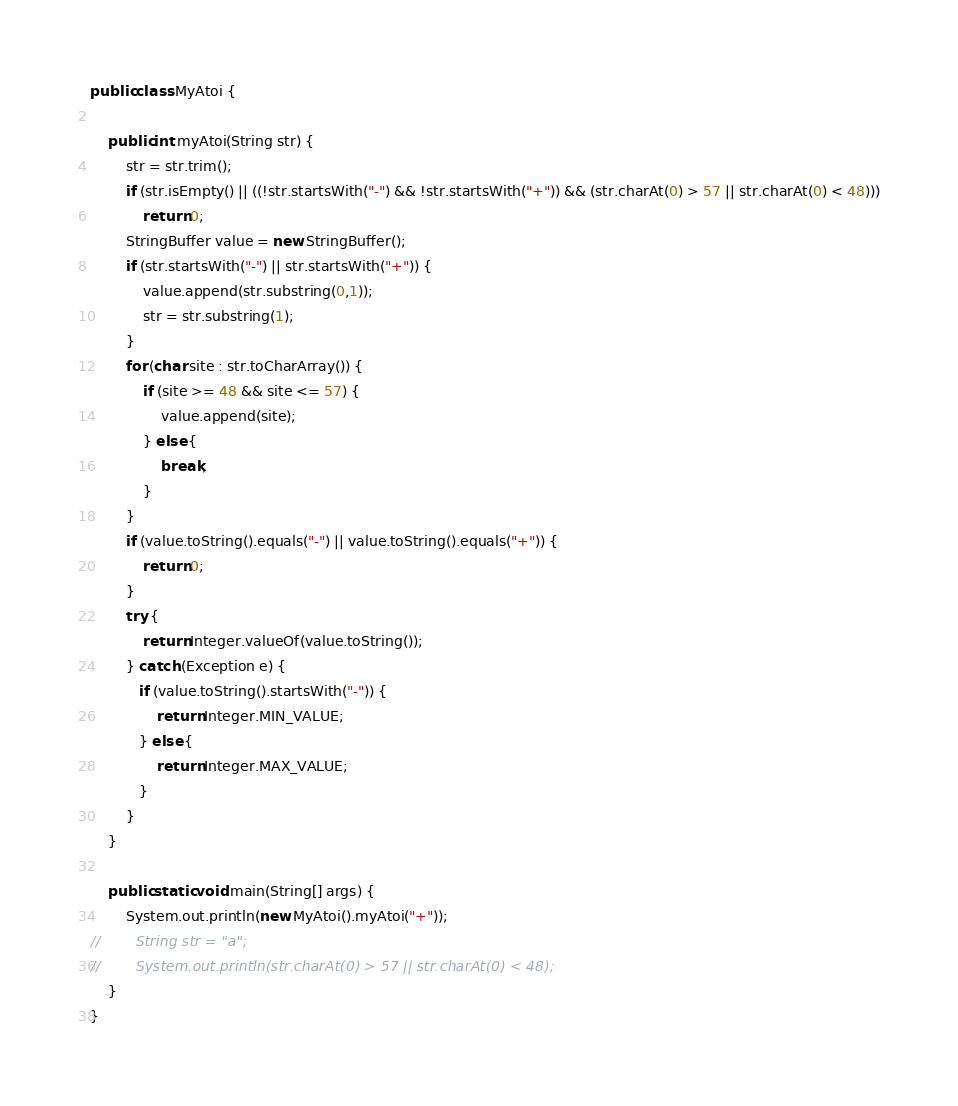<code> <loc_0><loc_0><loc_500><loc_500><_Java_>
public class MyAtoi {

    public int myAtoi(String str) {
        str = str.trim();
        if (str.isEmpty() || ((!str.startsWith("-") && !str.startsWith("+")) && (str.charAt(0) > 57 || str.charAt(0) < 48)))
            return 0;
        StringBuffer value = new StringBuffer();
        if (str.startsWith("-") || str.startsWith("+")) {
            value.append(str.substring(0,1));
            str = str.substring(1);
        }
        for (char site : str.toCharArray()) {
            if (site >= 48 && site <= 57) {
                value.append(site);
            } else {
                break;
            }
        }
        if (value.toString().equals("-") || value.toString().equals("+")) {
            return 0;
        }
        try {
            return Integer.valueOf(value.toString());
        } catch (Exception e) {
           if (value.toString().startsWith("-")) {
               return Integer.MIN_VALUE;
           } else {
               return Integer.MAX_VALUE;
           }
        }
    }

    public static void main(String[] args) {
        System.out.println(new MyAtoi().myAtoi("+"));
//        String str = "a";
//        System.out.println(str.charAt(0) > 57 || str.charAt(0) < 48);
    }
}
</code> 